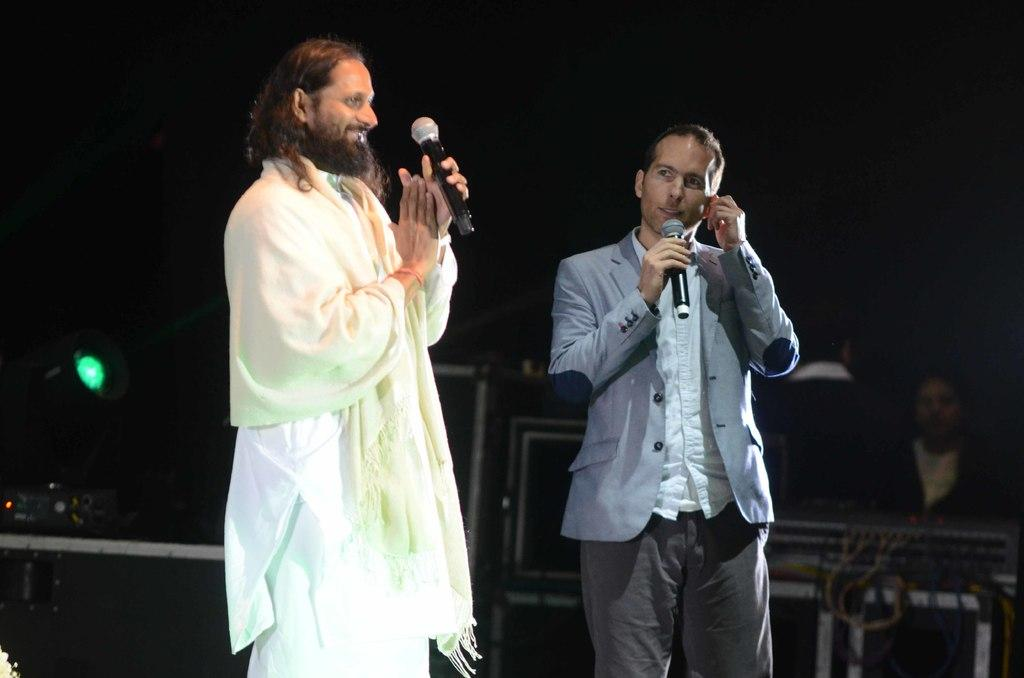How many people are present in the image? There are two people standing in the image. What are the two people holding? The two people are holding microphones. Can you describe the person in the background of the image? There is a person sitting in the background of the image. What type of objects can be seen in the background of the image? There are electronic devices visible in the background of the image. What type of brick is being used to build the business in the image? There is no brick or business present in the image; it features two people holding microphones and a person sitting in the background. What holiday is being celebrated in the image? There is no indication of a holiday being celebrated in the image. 